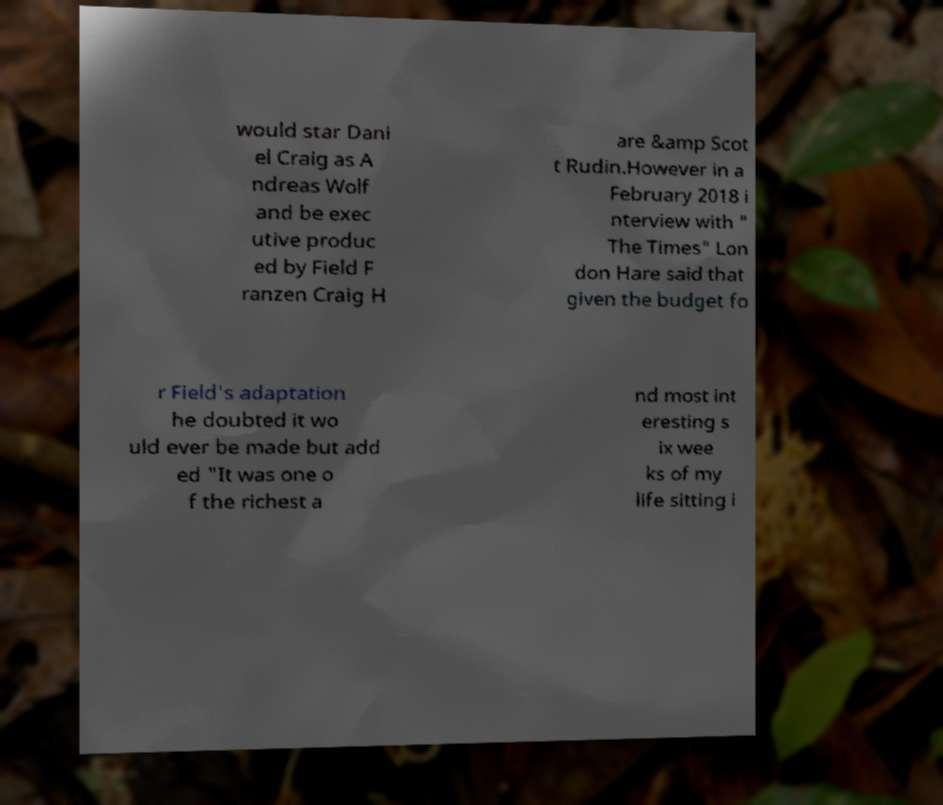Can you accurately transcribe the text from the provided image for me? would star Dani el Craig as A ndreas Wolf and be exec utive produc ed by Field F ranzen Craig H are &amp Scot t Rudin.However in a February 2018 i nterview with " The Times" Lon don Hare said that given the budget fo r Field's adaptation he doubted it wo uld ever be made but add ed "It was one o f the richest a nd most int eresting s ix wee ks of my life sitting i 